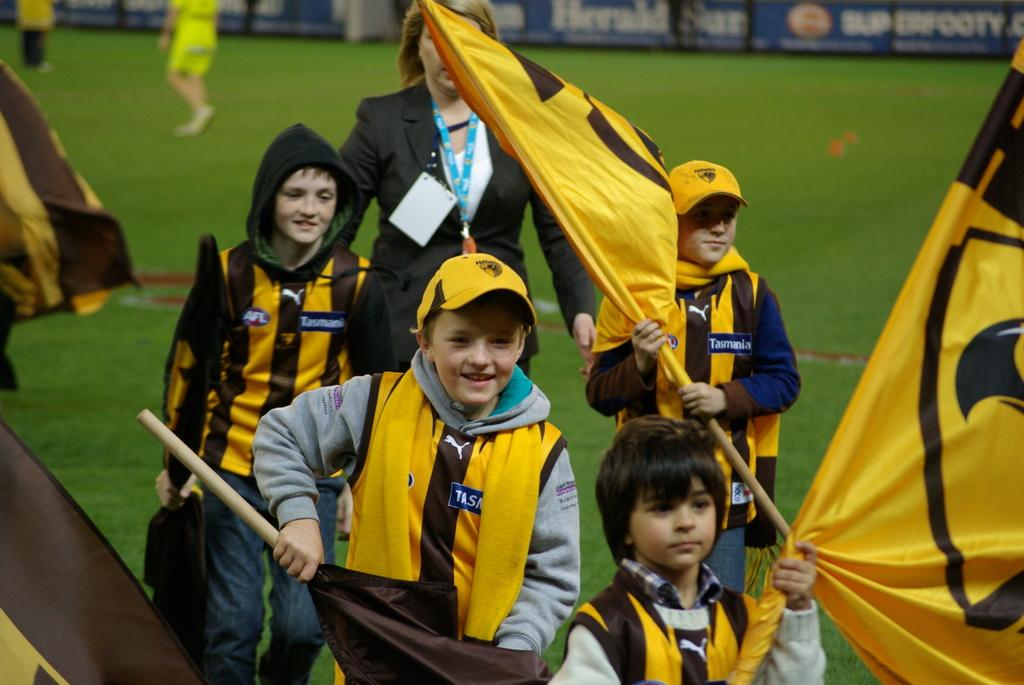Who is present in the image? There are kids in the image. What are the kids doing in the image? The kids are walking on the grass. What are the kids holding in their hands? The kids are holding flags in their hands. What type of rose can be seen in the image? There is no rose present in the image. What type of cord is being used by the kids in the image? There is no cord visible in the image; the kids are holding flags. 